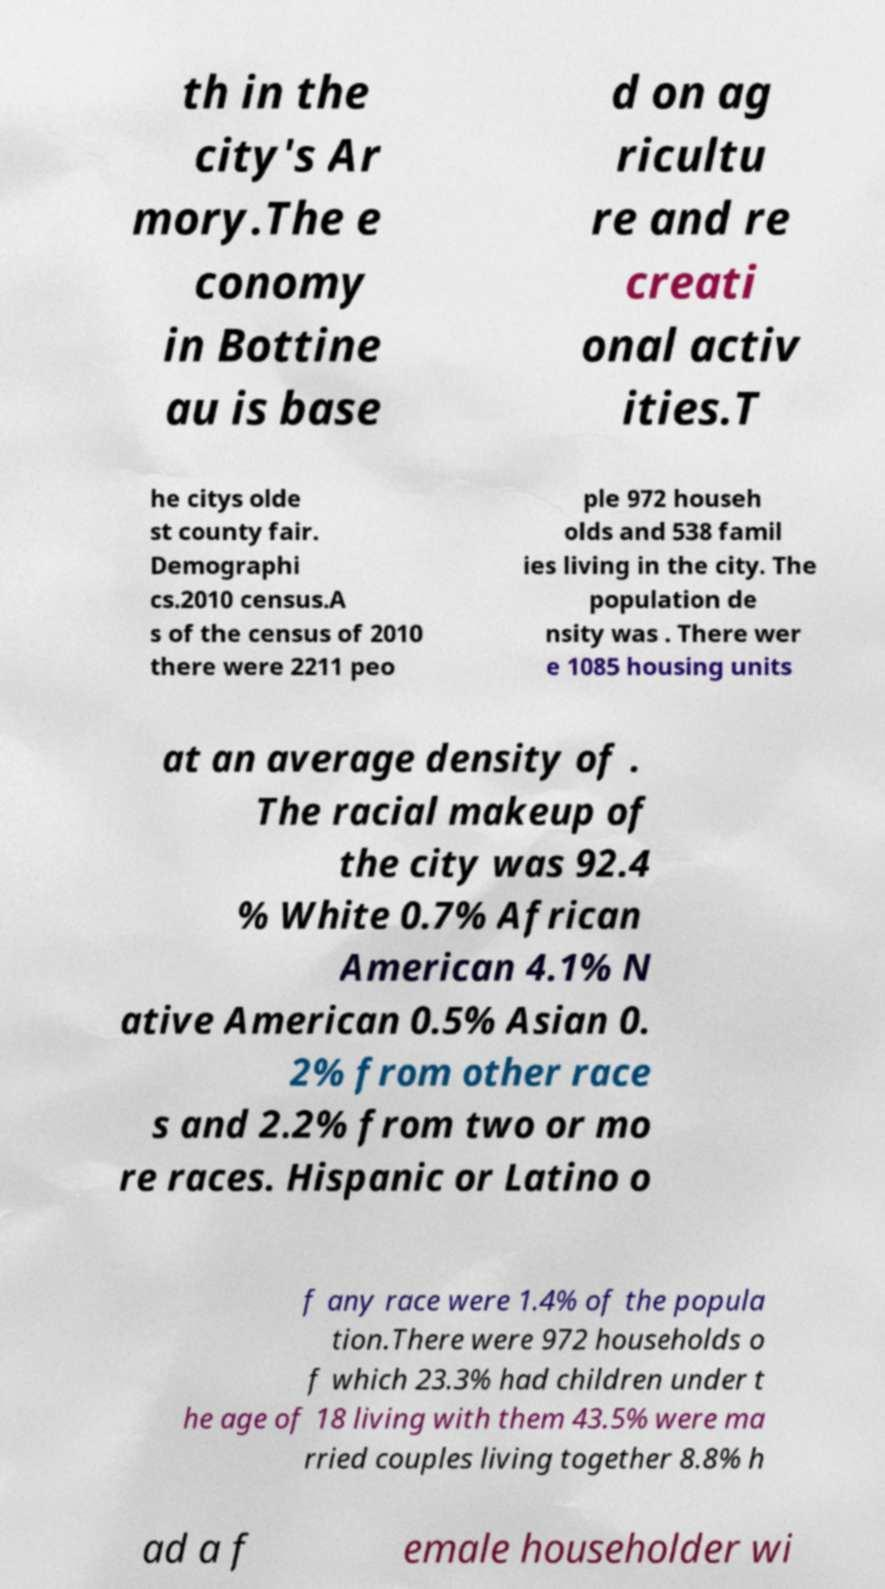There's text embedded in this image that I need extracted. Can you transcribe it verbatim? th in the city's Ar mory.The e conomy in Bottine au is base d on ag ricultu re and re creati onal activ ities.T he citys olde st county fair. Demographi cs.2010 census.A s of the census of 2010 there were 2211 peo ple 972 househ olds and 538 famil ies living in the city. The population de nsity was . There wer e 1085 housing units at an average density of . The racial makeup of the city was 92.4 % White 0.7% African American 4.1% N ative American 0.5% Asian 0. 2% from other race s and 2.2% from two or mo re races. Hispanic or Latino o f any race were 1.4% of the popula tion.There were 972 households o f which 23.3% had children under t he age of 18 living with them 43.5% were ma rried couples living together 8.8% h ad a f emale householder wi 